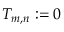Convert formula to latex. <formula><loc_0><loc_0><loc_500><loc_500>T _ { m , n } \colon = 0</formula> 